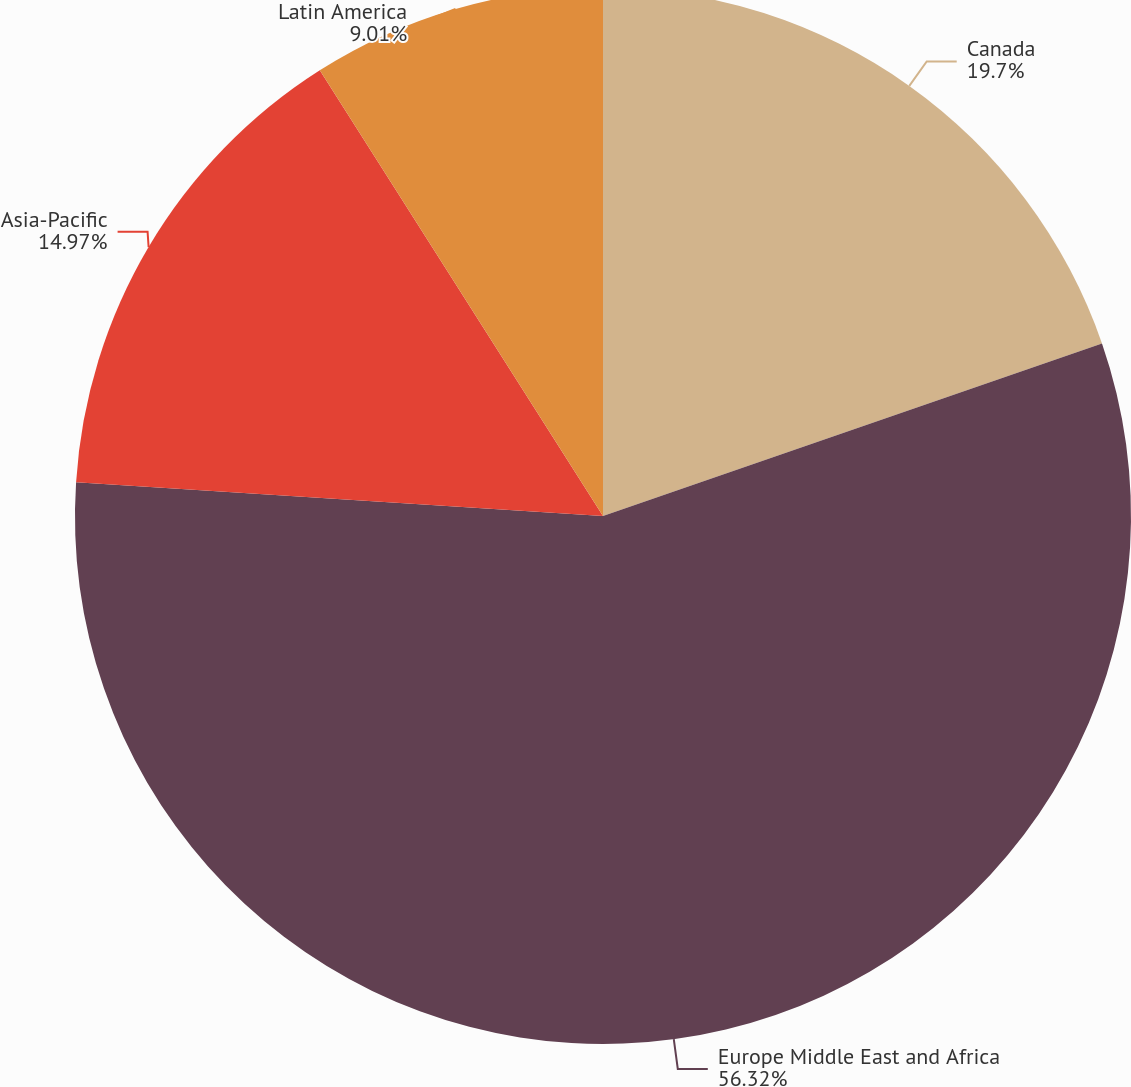Convert chart to OTSL. <chart><loc_0><loc_0><loc_500><loc_500><pie_chart><fcel>Canada<fcel>Europe Middle East and Africa<fcel>Asia-Pacific<fcel>Latin America<nl><fcel>19.7%<fcel>56.32%<fcel>14.97%<fcel>9.01%<nl></chart> 